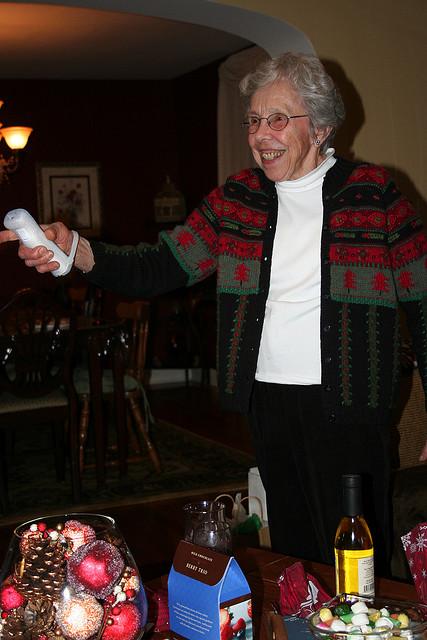Does this disprove the adage about 'old dogs' and tricks?
Short answer required. Yes. Is the woman young?
Give a very brief answer. No. What is in the big glass vase on the table?
Quick response, please. Ornaments. 